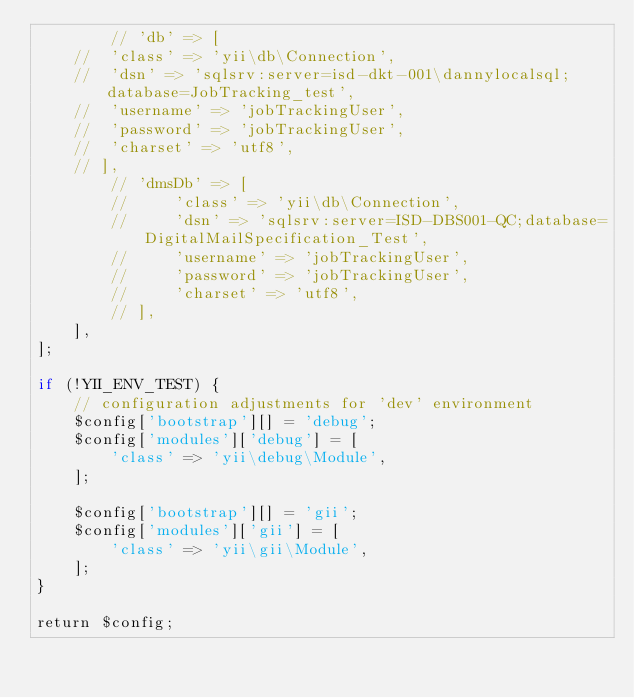Convert code to text. <code><loc_0><loc_0><loc_500><loc_500><_PHP_>        // 'db' => [
		// 	'class' => 'yii\db\Connection',
		// 	'dsn' => 'sqlsrv:server=isd-dkt-001\dannylocalsql;database=JobTracking_test',
		// 	'username' => 'jobTrackingUser',
		// 	'password' => 'jobTrackingUser',
		// 	'charset' => 'utf8',
		// ],
        // 'dmsDb' => [
        //     'class' => 'yii\db\Connection',
        //     'dsn' => 'sqlsrv:server=ISD-DBS001-QC;database=DigitalMailSpecification_Test',
        //     'username' => 'jobTrackingUser',
        //     'password' => 'jobTrackingUser',
        //     'charset' => 'utf8',
        // ],
    ],
];

if (!YII_ENV_TEST) {
    // configuration adjustments for 'dev' environment
    $config['bootstrap'][] = 'debug';
    $config['modules']['debug'] = [
        'class' => 'yii\debug\Module',
    ];

    $config['bootstrap'][] = 'gii';
    $config['modules']['gii'] = [
        'class' => 'yii\gii\Module',
    ];
}

return $config;</code> 